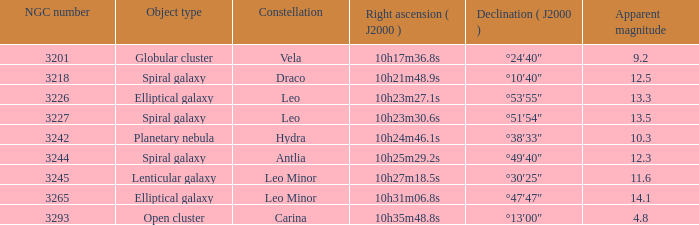What is the Apparent magnitude of a globular cluster? 9.2. 